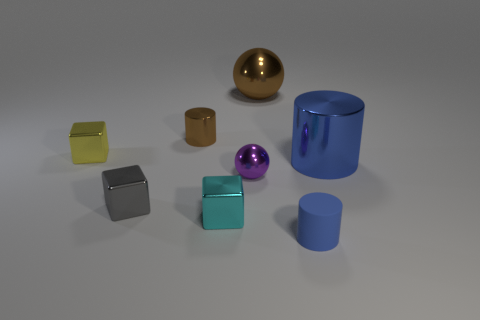Add 1 matte cylinders. How many objects exist? 9 Subtract all cubes. How many objects are left? 5 Add 3 cyan cubes. How many cyan cubes exist? 4 Subtract 0 cyan balls. How many objects are left? 8 Subtract all big yellow blocks. Subtract all brown shiny cylinders. How many objects are left? 7 Add 8 small gray blocks. How many small gray blocks are left? 9 